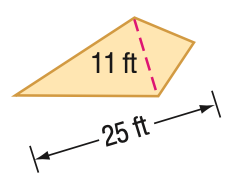Answer the mathemtical geometry problem and directly provide the correct option letter.
Question: Find the area of the kite.
Choices: A: 137.5 B: 255 C: 265 D: 550 A 